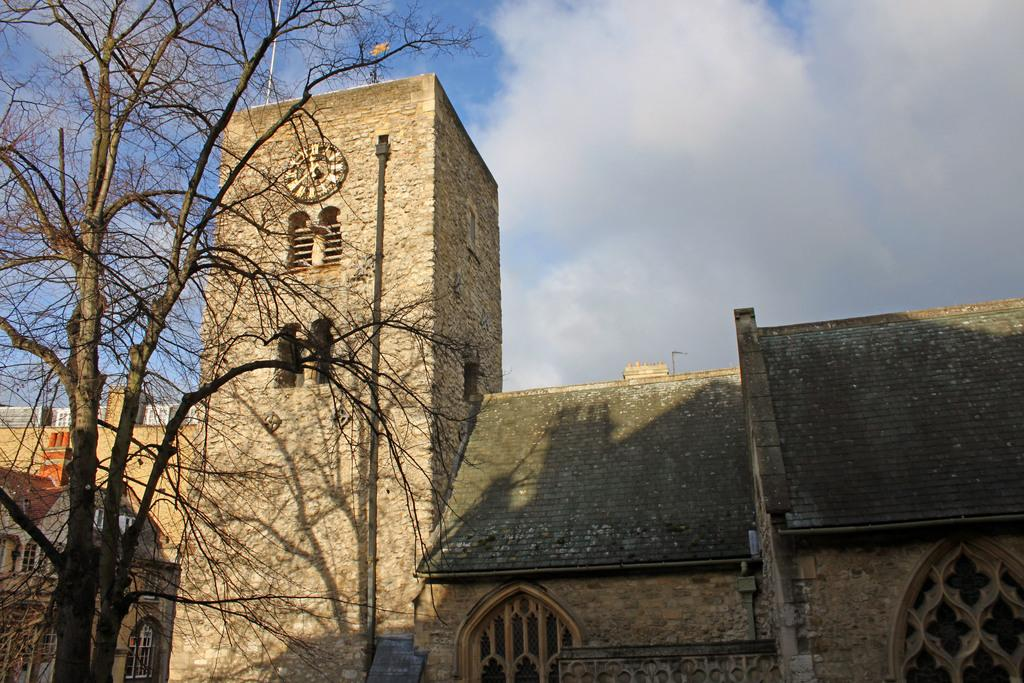What type of structures are present in the image? There are buildings in the image. Can you describe the colors of the buildings? The buildings have different colors: brown, green, orange, and white. What architectural features can be seen on the buildings? There are windows visible on the buildings. What other object can be seen in the image? There is a pipe in the image. What type of vegetation is present in the image? There is a tree in the image. What is visible in the background of the image? The sky is visible in the background of the image. Where is the playground located in the image? There is no playground present in the image. What type of drawer can be seen in the image? There is no drawer present in the image. 